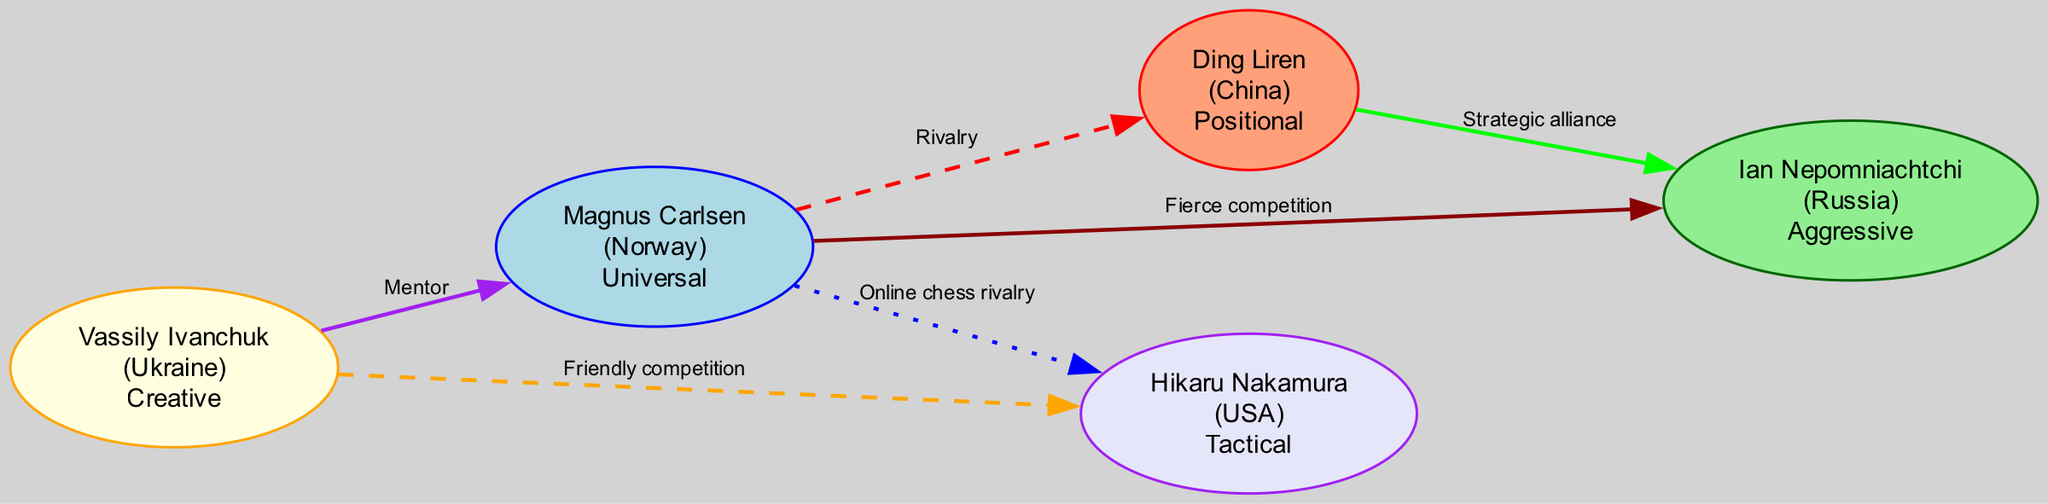What is the total number of grandmasters in the diagram? The diagram lists five grandmasters as nodes: Magnus Carlsen, Ding Liren, Ian Nepomniachtchi, Vassily Ivanchuk, and Hikaru Nakamura. By counting them, we see that there are five nodes.
Answer: 5 What relationship connects Magnus Carlsen and Hikaru Nakamura? The diagram indicates that there is an "Online chess rivalry" relationship between Magnus Carlsen and Hikaru Nakamura, which is shown as a dotted line in the diagram.
Answer: Online chess rivalry Which country does the grandmaster Vassily Ivanchuk represent? The node for Vassily Ivanchuk clearly states that he represents Ukraine as indicated next to his name in the diagram.
Answer: Ukraine Who is considered a mentor to Magnus Carlsen? The diagram shows Vassily Ivanchuk connected to Magnus Carlsen with a "Mentor" relationship. This indicates that Vassily Ivanchuk is the mentor to Magnus Carlsen.
Answer: Vassily Ivanchuk What type of playing style is associated with Ding Liren? The node for Ding Liren specifies that his style is "Positional," which is directly listed in the diagram next to his name.
Answer: Positional How many strategic alliances are represented in the diagram? There are two strategic alliances indicated in the diagram: one between Ding Liren and Ian Nepomniachtchi, and the other relationships do not classify as strategic alliances. Therefore, we count two edges labeled as "Strategic alliance."
Answer: 1 What are the styles of play for the grandmasters connected to Vassily Ivanchuk? Vassily Ivanchuk is connected to Magnus Carlsen (Universal) and Hikaru Nakamura (Tactical) through relationships of different types. By looking at the styles, Vassily Ivanchuk's connections highlight a contrast between Creative, Universal, and Tactical styles.
Answer: Creative, Universal, Tactical Which grandmaster has a fierce competition with Magnus Carlsen? According to the diagram, Ian Nepomniachtchi is shown as having a "Fierce competition" relationship with Magnus Carlsen, indicating a notable rivalry between these two grandmasters.
Answer: Ian Nepomniachtchi Which two grandmasters have a friendly competition? The diagram outlines a "Friendly competition" relationship between Vassily Ivanchuk and Hikaru Nakamura. Thus, these two grandmasters exhibit a friendly dynamic in their interactions.
Answer: Vassily Ivanchuk and Hikaru Nakamura 